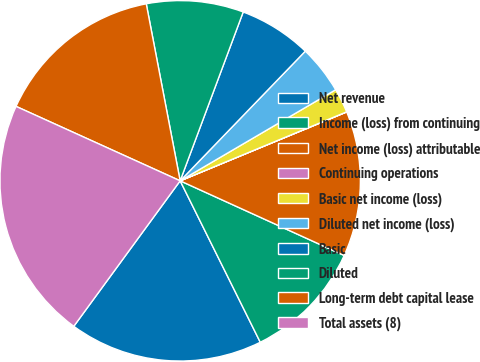Convert chart to OTSL. <chart><loc_0><loc_0><loc_500><loc_500><pie_chart><fcel>Net revenue<fcel>Income (loss) from continuing<fcel>Net income (loss) attributable<fcel>Continuing operations<fcel>Basic net income (loss)<fcel>Diluted net income (loss)<fcel>Basic<fcel>Diluted<fcel>Long-term debt capital lease<fcel>Total assets (8)<nl><fcel>17.38%<fcel>10.87%<fcel>13.04%<fcel>0.01%<fcel>2.18%<fcel>4.35%<fcel>6.53%<fcel>8.7%<fcel>15.21%<fcel>21.73%<nl></chart> 